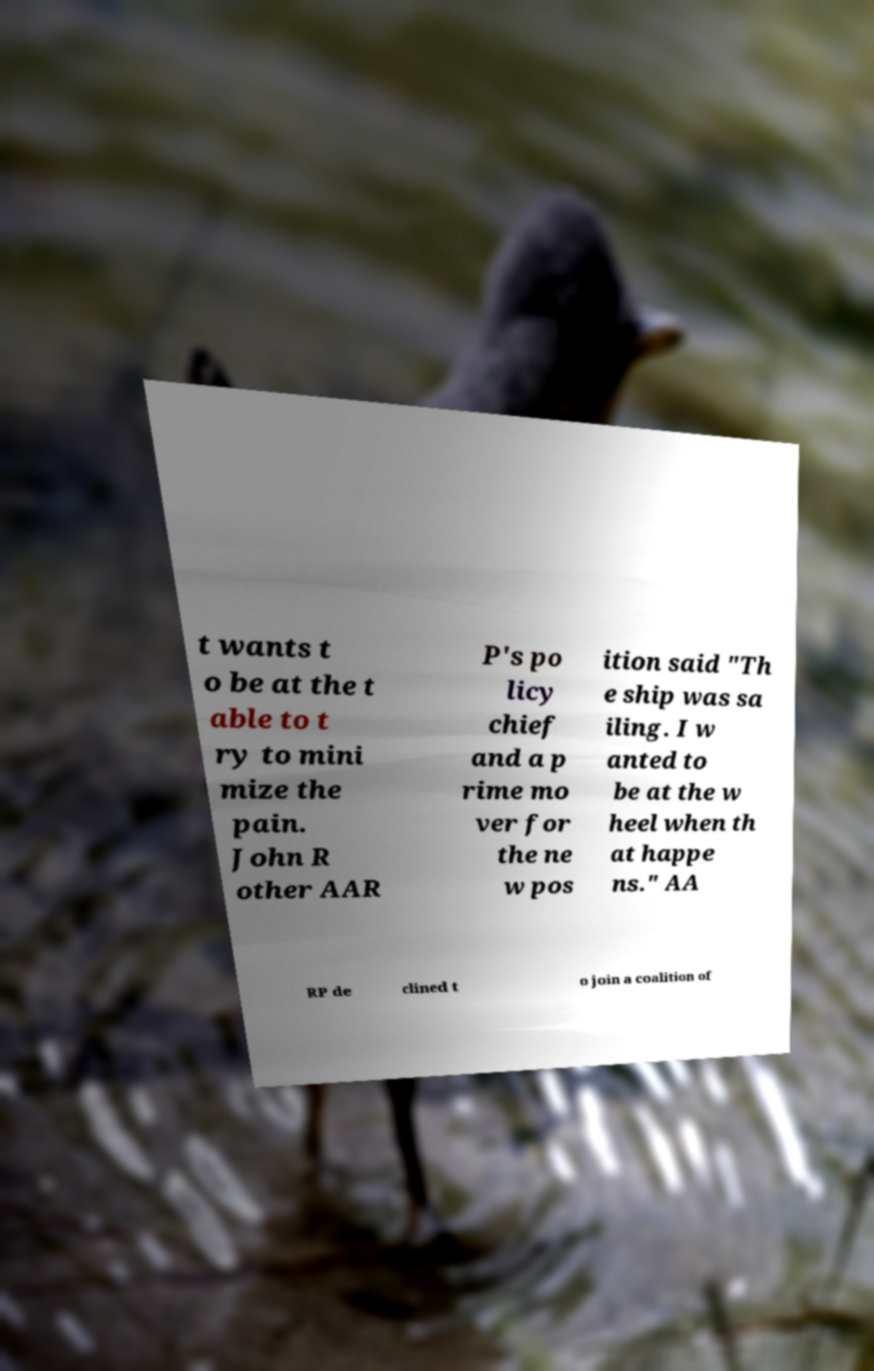What messages or text are displayed in this image? I need them in a readable, typed format. t wants t o be at the t able to t ry to mini mize the pain. John R other AAR P's po licy chief and a p rime mo ver for the ne w pos ition said "Th e ship was sa iling. I w anted to be at the w heel when th at happe ns." AA RP de clined t o join a coalition of 